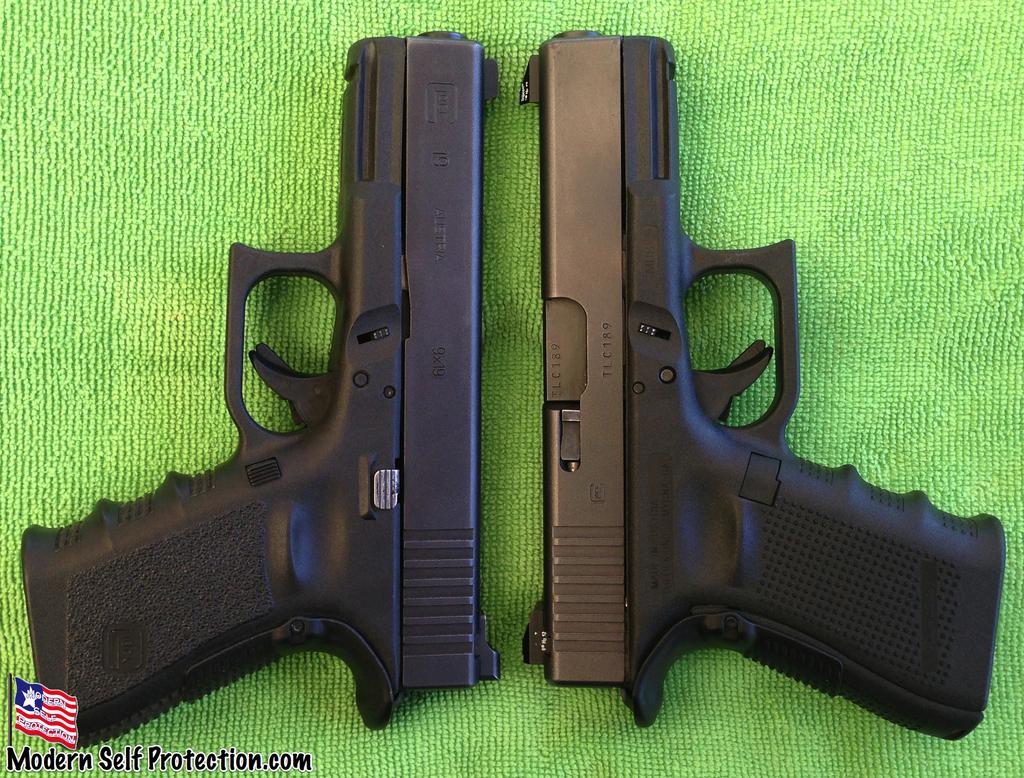What objects are present in the image? There are two guns in the image. What is the guns placed on? The guns are placed on a green cloth. What additional element can be seen in the image? There is a flag in the bottom left corner of the image. Are there any words or letters in the image? Yes, there is some text in the image. What type of texture can be seen on the top of the guns in the image? There is no specific texture mentioned or visible on the top of the guns in the image. 